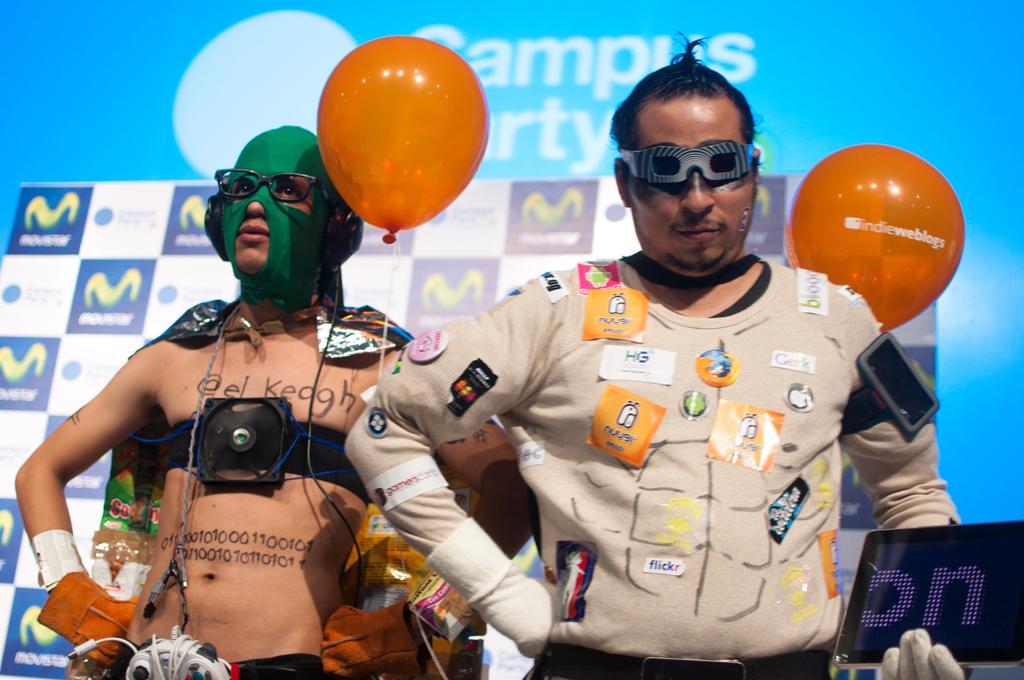In one or two sentences, can you explain what this image depicts? In this picture I can see there are two men standing and the person at right is wearing a shirt and there are few stickers pasted on the shirt. He is wearing gloves and holding a smartphone in his left hand and there is another man standing on to left, he is wearing a mask and there is a banner in the backdrop and there is a screen. 